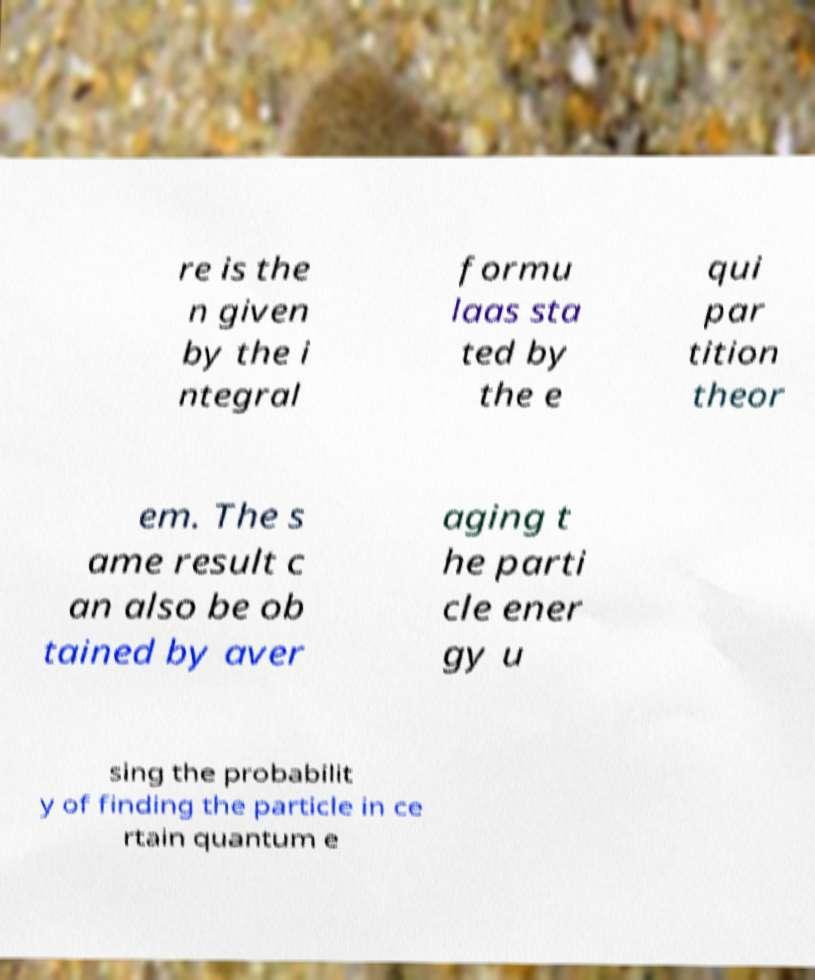Could you assist in decoding the text presented in this image and type it out clearly? re is the n given by the i ntegral formu laas sta ted by the e qui par tition theor em. The s ame result c an also be ob tained by aver aging t he parti cle ener gy u sing the probabilit y of finding the particle in ce rtain quantum e 